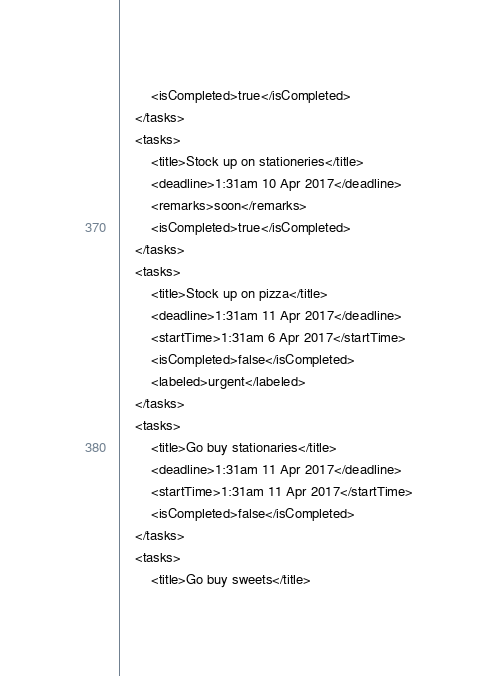<code> <loc_0><loc_0><loc_500><loc_500><_XML_>        <isCompleted>true</isCompleted>
    </tasks>
    <tasks>
        <title>Stock up on stationeries</title>
        <deadline>1:31am 10 Apr 2017</deadline>
        <remarks>soon</remarks>
        <isCompleted>true</isCompleted>
    </tasks>
    <tasks>
        <title>Stock up on pizza</title>
        <deadline>1:31am 11 Apr 2017</deadline>
        <startTime>1:31am 6 Apr 2017</startTime>
        <isCompleted>false</isCompleted>
        <labeled>urgent</labeled>
    </tasks>
    <tasks>
        <title>Go buy stationaries</title>
        <deadline>1:31am 11 Apr 2017</deadline>
        <startTime>1:31am 11 Apr 2017</startTime>
        <isCompleted>false</isCompleted>
    </tasks>
    <tasks>
        <title>Go buy sweets</title></code> 